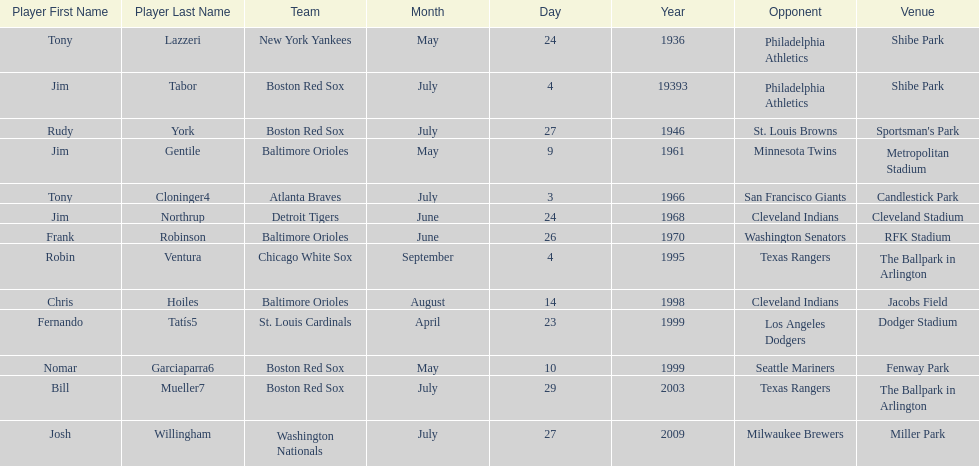On what date did the detroit tigers play the cleveland indians? June 24, 1968. 